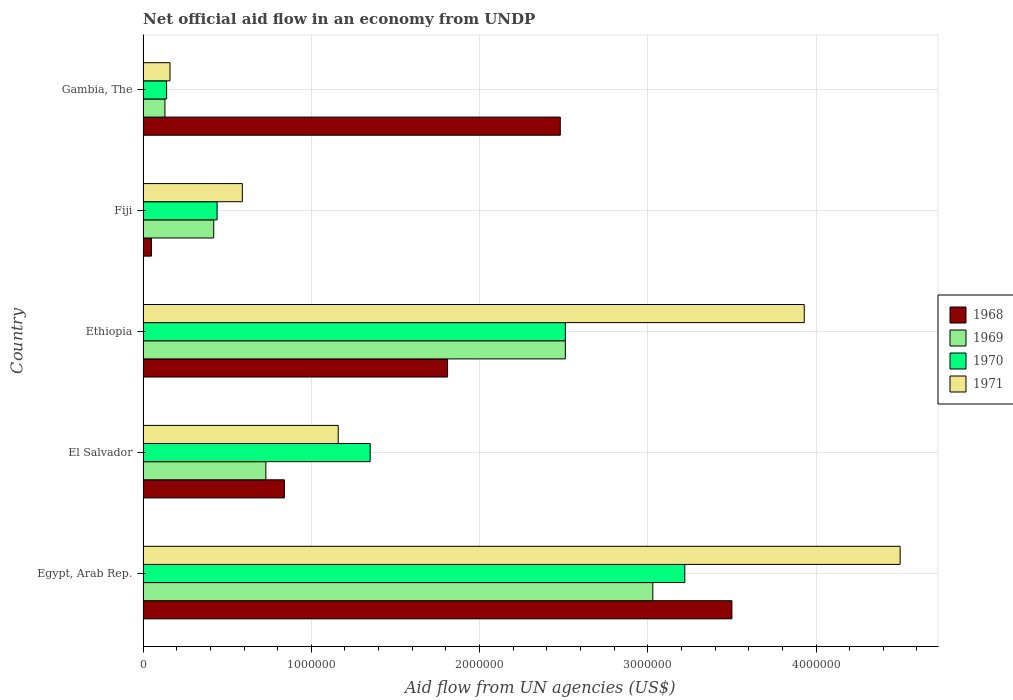How many groups of bars are there?
Give a very brief answer. 5. Are the number of bars per tick equal to the number of legend labels?
Your response must be concise. Yes. What is the label of the 5th group of bars from the top?
Keep it short and to the point. Egypt, Arab Rep. In how many cases, is the number of bars for a given country not equal to the number of legend labels?
Make the answer very short. 0. Across all countries, what is the maximum net official aid flow in 1970?
Your answer should be very brief. 3.22e+06. Across all countries, what is the minimum net official aid flow in 1969?
Keep it short and to the point. 1.30e+05. In which country was the net official aid flow in 1970 maximum?
Your answer should be compact. Egypt, Arab Rep. In which country was the net official aid flow in 1969 minimum?
Ensure brevity in your answer.  Gambia, The. What is the total net official aid flow in 1968 in the graph?
Keep it short and to the point. 8.68e+06. What is the difference between the net official aid flow in 1971 in El Salvador and that in Fiji?
Keep it short and to the point. 5.70e+05. What is the difference between the net official aid flow in 1968 in Egypt, Arab Rep. and the net official aid flow in 1970 in Gambia, The?
Make the answer very short. 3.36e+06. What is the average net official aid flow in 1970 per country?
Provide a succinct answer. 1.53e+06. What is the ratio of the net official aid flow in 1971 in Ethiopia to that in Fiji?
Offer a very short reply. 6.66. Is the difference between the net official aid flow in 1968 in El Salvador and Fiji greater than the difference between the net official aid flow in 1969 in El Salvador and Fiji?
Your response must be concise. Yes. What is the difference between the highest and the second highest net official aid flow in 1970?
Your response must be concise. 7.10e+05. What is the difference between the highest and the lowest net official aid flow in 1968?
Keep it short and to the point. 3.45e+06. In how many countries, is the net official aid flow in 1969 greater than the average net official aid flow in 1969 taken over all countries?
Provide a short and direct response. 2. What does the 3rd bar from the bottom in Ethiopia represents?
Your answer should be compact. 1970. Is it the case that in every country, the sum of the net official aid flow in 1969 and net official aid flow in 1970 is greater than the net official aid flow in 1971?
Offer a terse response. Yes. Does the graph contain grids?
Your response must be concise. Yes. What is the title of the graph?
Keep it short and to the point. Net official aid flow in an economy from UNDP. Does "2008" appear as one of the legend labels in the graph?
Keep it short and to the point. No. What is the label or title of the X-axis?
Your answer should be compact. Aid flow from UN agencies (US$). What is the label or title of the Y-axis?
Offer a very short reply. Country. What is the Aid flow from UN agencies (US$) in 1968 in Egypt, Arab Rep.?
Your answer should be very brief. 3.50e+06. What is the Aid flow from UN agencies (US$) of 1969 in Egypt, Arab Rep.?
Offer a very short reply. 3.03e+06. What is the Aid flow from UN agencies (US$) of 1970 in Egypt, Arab Rep.?
Your answer should be compact. 3.22e+06. What is the Aid flow from UN agencies (US$) in 1971 in Egypt, Arab Rep.?
Your response must be concise. 4.50e+06. What is the Aid flow from UN agencies (US$) in 1968 in El Salvador?
Provide a short and direct response. 8.40e+05. What is the Aid flow from UN agencies (US$) in 1969 in El Salvador?
Ensure brevity in your answer.  7.30e+05. What is the Aid flow from UN agencies (US$) in 1970 in El Salvador?
Give a very brief answer. 1.35e+06. What is the Aid flow from UN agencies (US$) in 1971 in El Salvador?
Keep it short and to the point. 1.16e+06. What is the Aid flow from UN agencies (US$) of 1968 in Ethiopia?
Provide a succinct answer. 1.81e+06. What is the Aid flow from UN agencies (US$) in 1969 in Ethiopia?
Provide a succinct answer. 2.51e+06. What is the Aid flow from UN agencies (US$) in 1970 in Ethiopia?
Your response must be concise. 2.51e+06. What is the Aid flow from UN agencies (US$) in 1971 in Ethiopia?
Offer a very short reply. 3.93e+06. What is the Aid flow from UN agencies (US$) in 1968 in Fiji?
Keep it short and to the point. 5.00e+04. What is the Aid flow from UN agencies (US$) in 1969 in Fiji?
Provide a succinct answer. 4.20e+05. What is the Aid flow from UN agencies (US$) in 1971 in Fiji?
Offer a very short reply. 5.90e+05. What is the Aid flow from UN agencies (US$) of 1968 in Gambia, The?
Make the answer very short. 2.48e+06. What is the Aid flow from UN agencies (US$) in 1969 in Gambia, The?
Offer a terse response. 1.30e+05. What is the Aid flow from UN agencies (US$) of 1970 in Gambia, The?
Make the answer very short. 1.40e+05. Across all countries, what is the maximum Aid flow from UN agencies (US$) in 1968?
Your answer should be very brief. 3.50e+06. Across all countries, what is the maximum Aid flow from UN agencies (US$) of 1969?
Offer a terse response. 3.03e+06. Across all countries, what is the maximum Aid flow from UN agencies (US$) in 1970?
Give a very brief answer. 3.22e+06. Across all countries, what is the maximum Aid flow from UN agencies (US$) of 1971?
Offer a very short reply. 4.50e+06. Across all countries, what is the minimum Aid flow from UN agencies (US$) of 1968?
Your response must be concise. 5.00e+04. Across all countries, what is the minimum Aid flow from UN agencies (US$) in 1970?
Offer a very short reply. 1.40e+05. What is the total Aid flow from UN agencies (US$) in 1968 in the graph?
Your response must be concise. 8.68e+06. What is the total Aid flow from UN agencies (US$) in 1969 in the graph?
Your answer should be compact. 6.82e+06. What is the total Aid flow from UN agencies (US$) of 1970 in the graph?
Provide a succinct answer. 7.66e+06. What is the total Aid flow from UN agencies (US$) in 1971 in the graph?
Make the answer very short. 1.03e+07. What is the difference between the Aid flow from UN agencies (US$) in 1968 in Egypt, Arab Rep. and that in El Salvador?
Offer a very short reply. 2.66e+06. What is the difference between the Aid flow from UN agencies (US$) in 1969 in Egypt, Arab Rep. and that in El Salvador?
Make the answer very short. 2.30e+06. What is the difference between the Aid flow from UN agencies (US$) of 1970 in Egypt, Arab Rep. and that in El Salvador?
Ensure brevity in your answer.  1.87e+06. What is the difference between the Aid flow from UN agencies (US$) in 1971 in Egypt, Arab Rep. and that in El Salvador?
Offer a terse response. 3.34e+06. What is the difference between the Aid flow from UN agencies (US$) of 1968 in Egypt, Arab Rep. and that in Ethiopia?
Your response must be concise. 1.69e+06. What is the difference between the Aid flow from UN agencies (US$) of 1969 in Egypt, Arab Rep. and that in Ethiopia?
Provide a succinct answer. 5.20e+05. What is the difference between the Aid flow from UN agencies (US$) of 1970 in Egypt, Arab Rep. and that in Ethiopia?
Your answer should be compact. 7.10e+05. What is the difference between the Aid flow from UN agencies (US$) in 1971 in Egypt, Arab Rep. and that in Ethiopia?
Offer a terse response. 5.70e+05. What is the difference between the Aid flow from UN agencies (US$) in 1968 in Egypt, Arab Rep. and that in Fiji?
Provide a succinct answer. 3.45e+06. What is the difference between the Aid flow from UN agencies (US$) of 1969 in Egypt, Arab Rep. and that in Fiji?
Your answer should be compact. 2.61e+06. What is the difference between the Aid flow from UN agencies (US$) of 1970 in Egypt, Arab Rep. and that in Fiji?
Provide a short and direct response. 2.78e+06. What is the difference between the Aid flow from UN agencies (US$) of 1971 in Egypt, Arab Rep. and that in Fiji?
Provide a short and direct response. 3.91e+06. What is the difference between the Aid flow from UN agencies (US$) in 1968 in Egypt, Arab Rep. and that in Gambia, The?
Your response must be concise. 1.02e+06. What is the difference between the Aid flow from UN agencies (US$) of 1969 in Egypt, Arab Rep. and that in Gambia, The?
Offer a very short reply. 2.90e+06. What is the difference between the Aid flow from UN agencies (US$) in 1970 in Egypt, Arab Rep. and that in Gambia, The?
Offer a very short reply. 3.08e+06. What is the difference between the Aid flow from UN agencies (US$) in 1971 in Egypt, Arab Rep. and that in Gambia, The?
Your answer should be very brief. 4.34e+06. What is the difference between the Aid flow from UN agencies (US$) in 1968 in El Salvador and that in Ethiopia?
Your response must be concise. -9.70e+05. What is the difference between the Aid flow from UN agencies (US$) of 1969 in El Salvador and that in Ethiopia?
Make the answer very short. -1.78e+06. What is the difference between the Aid flow from UN agencies (US$) in 1970 in El Salvador and that in Ethiopia?
Your answer should be very brief. -1.16e+06. What is the difference between the Aid flow from UN agencies (US$) in 1971 in El Salvador and that in Ethiopia?
Ensure brevity in your answer.  -2.77e+06. What is the difference between the Aid flow from UN agencies (US$) of 1968 in El Salvador and that in Fiji?
Make the answer very short. 7.90e+05. What is the difference between the Aid flow from UN agencies (US$) in 1970 in El Salvador and that in Fiji?
Provide a short and direct response. 9.10e+05. What is the difference between the Aid flow from UN agencies (US$) of 1971 in El Salvador and that in Fiji?
Your response must be concise. 5.70e+05. What is the difference between the Aid flow from UN agencies (US$) of 1968 in El Salvador and that in Gambia, The?
Provide a succinct answer. -1.64e+06. What is the difference between the Aid flow from UN agencies (US$) of 1969 in El Salvador and that in Gambia, The?
Provide a short and direct response. 6.00e+05. What is the difference between the Aid flow from UN agencies (US$) in 1970 in El Salvador and that in Gambia, The?
Offer a very short reply. 1.21e+06. What is the difference between the Aid flow from UN agencies (US$) in 1968 in Ethiopia and that in Fiji?
Your response must be concise. 1.76e+06. What is the difference between the Aid flow from UN agencies (US$) of 1969 in Ethiopia and that in Fiji?
Your answer should be compact. 2.09e+06. What is the difference between the Aid flow from UN agencies (US$) of 1970 in Ethiopia and that in Fiji?
Keep it short and to the point. 2.07e+06. What is the difference between the Aid flow from UN agencies (US$) in 1971 in Ethiopia and that in Fiji?
Offer a terse response. 3.34e+06. What is the difference between the Aid flow from UN agencies (US$) in 1968 in Ethiopia and that in Gambia, The?
Provide a short and direct response. -6.70e+05. What is the difference between the Aid flow from UN agencies (US$) of 1969 in Ethiopia and that in Gambia, The?
Ensure brevity in your answer.  2.38e+06. What is the difference between the Aid flow from UN agencies (US$) in 1970 in Ethiopia and that in Gambia, The?
Your answer should be very brief. 2.37e+06. What is the difference between the Aid flow from UN agencies (US$) of 1971 in Ethiopia and that in Gambia, The?
Offer a very short reply. 3.77e+06. What is the difference between the Aid flow from UN agencies (US$) of 1968 in Fiji and that in Gambia, The?
Make the answer very short. -2.43e+06. What is the difference between the Aid flow from UN agencies (US$) in 1969 in Fiji and that in Gambia, The?
Keep it short and to the point. 2.90e+05. What is the difference between the Aid flow from UN agencies (US$) in 1970 in Fiji and that in Gambia, The?
Provide a short and direct response. 3.00e+05. What is the difference between the Aid flow from UN agencies (US$) of 1968 in Egypt, Arab Rep. and the Aid flow from UN agencies (US$) of 1969 in El Salvador?
Your response must be concise. 2.77e+06. What is the difference between the Aid flow from UN agencies (US$) in 1968 in Egypt, Arab Rep. and the Aid flow from UN agencies (US$) in 1970 in El Salvador?
Offer a very short reply. 2.15e+06. What is the difference between the Aid flow from UN agencies (US$) in 1968 in Egypt, Arab Rep. and the Aid flow from UN agencies (US$) in 1971 in El Salvador?
Your answer should be very brief. 2.34e+06. What is the difference between the Aid flow from UN agencies (US$) in 1969 in Egypt, Arab Rep. and the Aid flow from UN agencies (US$) in 1970 in El Salvador?
Make the answer very short. 1.68e+06. What is the difference between the Aid flow from UN agencies (US$) of 1969 in Egypt, Arab Rep. and the Aid flow from UN agencies (US$) of 1971 in El Salvador?
Your answer should be very brief. 1.87e+06. What is the difference between the Aid flow from UN agencies (US$) in 1970 in Egypt, Arab Rep. and the Aid flow from UN agencies (US$) in 1971 in El Salvador?
Ensure brevity in your answer.  2.06e+06. What is the difference between the Aid flow from UN agencies (US$) of 1968 in Egypt, Arab Rep. and the Aid flow from UN agencies (US$) of 1969 in Ethiopia?
Your response must be concise. 9.90e+05. What is the difference between the Aid flow from UN agencies (US$) of 1968 in Egypt, Arab Rep. and the Aid flow from UN agencies (US$) of 1970 in Ethiopia?
Make the answer very short. 9.90e+05. What is the difference between the Aid flow from UN agencies (US$) of 1968 in Egypt, Arab Rep. and the Aid flow from UN agencies (US$) of 1971 in Ethiopia?
Your answer should be compact. -4.30e+05. What is the difference between the Aid flow from UN agencies (US$) of 1969 in Egypt, Arab Rep. and the Aid flow from UN agencies (US$) of 1970 in Ethiopia?
Your answer should be very brief. 5.20e+05. What is the difference between the Aid flow from UN agencies (US$) of 1969 in Egypt, Arab Rep. and the Aid flow from UN agencies (US$) of 1971 in Ethiopia?
Give a very brief answer. -9.00e+05. What is the difference between the Aid flow from UN agencies (US$) in 1970 in Egypt, Arab Rep. and the Aid flow from UN agencies (US$) in 1971 in Ethiopia?
Ensure brevity in your answer.  -7.10e+05. What is the difference between the Aid flow from UN agencies (US$) in 1968 in Egypt, Arab Rep. and the Aid flow from UN agencies (US$) in 1969 in Fiji?
Offer a terse response. 3.08e+06. What is the difference between the Aid flow from UN agencies (US$) in 1968 in Egypt, Arab Rep. and the Aid flow from UN agencies (US$) in 1970 in Fiji?
Your response must be concise. 3.06e+06. What is the difference between the Aid flow from UN agencies (US$) in 1968 in Egypt, Arab Rep. and the Aid flow from UN agencies (US$) in 1971 in Fiji?
Offer a terse response. 2.91e+06. What is the difference between the Aid flow from UN agencies (US$) of 1969 in Egypt, Arab Rep. and the Aid flow from UN agencies (US$) of 1970 in Fiji?
Ensure brevity in your answer.  2.59e+06. What is the difference between the Aid flow from UN agencies (US$) in 1969 in Egypt, Arab Rep. and the Aid flow from UN agencies (US$) in 1971 in Fiji?
Provide a succinct answer. 2.44e+06. What is the difference between the Aid flow from UN agencies (US$) in 1970 in Egypt, Arab Rep. and the Aid flow from UN agencies (US$) in 1971 in Fiji?
Give a very brief answer. 2.63e+06. What is the difference between the Aid flow from UN agencies (US$) in 1968 in Egypt, Arab Rep. and the Aid flow from UN agencies (US$) in 1969 in Gambia, The?
Provide a succinct answer. 3.37e+06. What is the difference between the Aid flow from UN agencies (US$) of 1968 in Egypt, Arab Rep. and the Aid flow from UN agencies (US$) of 1970 in Gambia, The?
Offer a very short reply. 3.36e+06. What is the difference between the Aid flow from UN agencies (US$) of 1968 in Egypt, Arab Rep. and the Aid flow from UN agencies (US$) of 1971 in Gambia, The?
Keep it short and to the point. 3.34e+06. What is the difference between the Aid flow from UN agencies (US$) of 1969 in Egypt, Arab Rep. and the Aid flow from UN agencies (US$) of 1970 in Gambia, The?
Offer a terse response. 2.89e+06. What is the difference between the Aid flow from UN agencies (US$) of 1969 in Egypt, Arab Rep. and the Aid flow from UN agencies (US$) of 1971 in Gambia, The?
Offer a terse response. 2.87e+06. What is the difference between the Aid flow from UN agencies (US$) in 1970 in Egypt, Arab Rep. and the Aid flow from UN agencies (US$) in 1971 in Gambia, The?
Your response must be concise. 3.06e+06. What is the difference between the Aid flow from UN agencies (US$) in 1968 in El Salvador and the Aid flow from UN agencies (US$) in 1969 in Ethiopia?
Give a very brief answer. -1.67e+06. What is the difference between the Aid flow from UN agencies (US$) of 1968 in El Salvador and the Aid flow from UN agencies (US$) of 1970 in Ethiopia?
Your answer should be compact. -1.67e+06. What is the difference between the Aid flow from UN agencies (US$) of 1968 in El Salvador and the Aid flow from UN agencies (US$) of 1971 in Ethiopia?
Ensure brevity in your answer.  -3.09e+06. What is the difference between the Aid flow from UN agencies (US$) of 1969 in El Salvador and the Aid flow from UN agencies (US$) of 1970 in Ethiopia?
Offer a terse response. -1.78e+06. What is the difference between the Aid flow from UN agencies (US$) in 1969 in El Salvador and the Aid flow from UN agencies (US$) in 1971 in Ethiopia?
Ensure brevity in your answer.  -3.20e+06. What is the difference between the Aid flow from UN agencies (US$) in 1970 in El Salvador and the Aid flow from UN agencies (US$) in 1971 in Ethiopia?
Provide a succinct answer. -2.58e+06. What is the difference between the Aid flow from UN agencies (US$) of 1968 in El Salvador and the Aid flow from UN agencies (US$) of 1969 in Fiji?
Offer a terse response. 4.20e+05. What is the difference between the Aid flow from UN agencies (US$) of 1968 in El Salvador and the Aid flow from UN agencies (US$) of 1971 in Fiji?
Make the answer very short. 2.50e+05. What is the difference between the Aid flow from UN agencies (US$) of 1969 in El Salvador and the Aid flow from UN agencies (US$) of 1971 in Fiji?
Your response must be concise. 1.40e+05. What is the difference between the Aid flow from UN agencies (US$) of 1970 in El Salvador and the Aid flow from UN agencies (US$) of 1971 in Fiji?
Provide a short and direct response. 7.60e+05. What is the difference between the Aid flow from UN agencies (US$) in 1968 in El Salvador and the Aid flow from UN agencies (US$) in 1969 in Gambia, The?
Your answer should be compact. 7.10e+05. What is the difference between the Aid flow from UN agencies (US$) of 1968 in El Salvador and the Aid flow from UN agencies (US$) of 1971 in Gambia, The?
Offer a terse response. 6.80e+05. What is the difference between the Aid flow from UN agencies (US$) in 1969 in El Salvador and the Aid flow from UN agencies (US$) in 1970 in Gambia, The?
Ensure brevity in your answer.  5.90e+05. What is the difference between the Aid flow from UN agencies (US$) of 1969 in El Salvador and the Aid flow from UN agencies (US$) of 1971 in Gambia, The?
Give a very brief answer. 5.70e+05. What is the difference between the Aid flow from UN agencies (US$) of 1970 in El Salvador and the Aid flow from UN agencies (US$) of 1971 in Gambia, The?
Your response must be concise. 1.19e+06. What is the difference between the Aid flow from UN agencies (US$) of 1968 in Ethiopia and the Aid flow from UN agencies (US$) of 1969 in Fiji?
Provide a short and direct response. 1.39e+06. What is the difference between the Aid flow from UN agencies (US$) of 1968 in Ethiopia and the Aid flow from UN agencies (US$) of 1970 in Fiji?
Provide a short and direct response. 1.37e+06. What is the difference between the Aid flow from UN agencies (US$) in 1968 in Ethiopia and the Aid flow from UN agencies (US$) in 1971 in Fiji?
Provide a short and direct response. 1.22e+06. What is the difference between the Aid flow from UN agencies (US$) of 1969 in Ethiopia and the Aid flow from UN agencies (US$) of 1970 in Fiji?
Give a very brief answer. 2.07e+06. What is the difference between the Aid flow from UN agencies (US$) in 1969 in Ethiopia and the Aid flow from UN agencies (US$) in 1971 in Fiji?
Your answer should be very brief. 1.92e+06. What is the difference between the Aid flow from UN agencies (US$) of 1970 in Ethiopia and the Aid flow from UN agencies (US$) of 1971 in Fiji?
Offer a terse response. 1.92e+06. What is the difference between the Aid flow from UN agencies (US$) in 1968 in Ethiopia and the Aid flow from UN agencies (US$) in 1969 in Gambia, The?
Your answer should be compact. 1.68e+06. What is the difference between the Aid flow from UN agencies (US$) in 1968 in Ethiopia and the Aid flow from UN agencies (US$) in 1970 in Gambia, The?
Ensure brevity in your answer.  1.67e+06. What is the difference between the Aid flow from UN agencies (US$) of 1968 in Ethiopia and the Aid flow from UN agencies (US$) of 1971 in Gambia, The?
Your answer should be very brief. 1.65e+06. What is the difference between the Aid flow from UN agencies (US$) of 1969 in Ethiopia and the Aid flow from UN agencies (US$) of 1970 in Gambia, The?
Ensure brevity in your answer.  2.37e+06. What is the difference between the Aid flow from UN agencies (US$) in 1969 in Ethiopia and the Aid flow from UN agencies (US$) in 1971 in Gambia, The?
Provide a succinct answer. 2.35e+06. What is the difference between the Aid flow from UN agencies (US$) of 1970 in Ethiopia and the Aid flow from UN agencies (US$) of 1971 in Gambia, The?
Give a very brief answer. 2.35e+06. What is the difference between the Aid flow from UN agencies (US$) of 1968 in Fiji and the Aid flow from UN agencies (US$) of 1969 in Gambia, The?
Give a very brief answer. -8.00e+04. What is the difference between the Aid flow from UN agencies (US$) of 1968 in Fiji and the Aid flow from UN agencies (US$) of 1970 in Gambia, The?
Offer a very short reply. -9.00e+04. What is the difference between the Aid flow from UN agencies (US$) of 1968 in Fiji and the Aid flow from UN agencies (US$) of 1971 in Gambia, The?
Ensure brevity in your answer.  -1.10e+05. What is the difference between the Aid flow from UN agencies (US$) in 1969 in Fiji and the Aid flow from UN agencies (US$) in 1970 in Gambia, The?
Offer a terse response. 2.80e+05. What is the difference between the Aid flow from UN agencies (US$) of 1970 in Fiji and the Aid flow from UN agencies (US$) of 1971 in Gambia, The?
Keep it short and to the point. 2.80e+05. What is the average Aid flow from UN agencies (US$) in 1968 per country?
Offer a very short reply. 1.74e+06. What is the average Aid flow from UN agencies (US$) in 1969 per country?
Provide a short and direct response. 1.36e+06. What is the average Aid flow from UN agencies (US$) in 1970 per country?
Provide a short and direct response. 1.53e+06. What is the average Aid flow from UN agencies (US$) in 1971 per country?
Offer a terse response. 2.07e+06. What is the difference between the Aid flow from UN agencies (US$) in 1968 and Aid flow from UN agencies (US$) in 1970 in Egypt, Arab Rep.?
Make the answer very short. 2.80e+05. What is the difference between the Aid flow from UN agencies (US$) of 1969 and Aid flow from UN agencies (US$) of 1971 in Egypt, Arab Rep.?
Give a very brief answer. -1.47e+06. What is the difference between the Aid flow from UN agencies (US$) in 1970 and Aid flow from UN agencies (US$) in 1971 in Egypt, Arab Rep.?
Make the answer very short. -1.28e+06. What is the difference between the Aid flow from UN agencies (US$) in 1968 and Aid flow from UN agencies (US$) in 1970 in El Salvador?
Make the answer very short. -5.10e+05. What is the difference between the Aid flow from UN agencies (US$) of 1968 and Aid flow from UN agencies (US$) of 1971 in El Salvador?
Your answer should be very brief. -3.20e+05. What is the difference between the Aid flow from UN agencies (US$) of 1969 and Aid flow from UN agencies (US$) of 1970 in El Salvador?
Keep it short and to the point. -6.20e+05. What is the difference between the Aid flow from UN agencies (US$) of 1969 and Aid flow from UN agencies (US$) of 1971 in El Salvador?
Offer a terse response. -4.30e+05. What is the difference between the Aid flow from UN agencies (US$) of 1970 and Aid flow from UN agencies (US$) of 1971 in El Salvador?
Offer a very short reply. 1.90e+05. What is the difference between the Aid flow from UN agencies (US$) in 1968 and Aid flow from UN agencies (US$) in 1969 in Ethiopia?
Keep it short and to the point. -7.00e+05. What is the difference between the Aid flow from UN agencies (US$) in 1968 and Aid flow from UN agencies (US$) in 1970 in Ethiopia?
Give a very brief answer. -7.00e+05. What is the difference between the Aid flow from UN agencies (US$) of 1968 and Aid flow from UN agencies (US$) of 1971 in Ethiopia?
Make the answer very short. -2.12e+06. What is the difference between the Aid flow from UN agencies (US$) in 1969 and Aid flow from UN agencies (US$) in 1971 in Ethiopia?
Give a very brief answer. -1.42e+06. What is the difference between the Aid flow from UN agencies (US$) of 1970 and Aid flow from UN agencies (US$) of 1971 in Ethiopia?
Keep it short and to the point. -1.42e+06. What is the difference between the Aid flow from UN agencies (US$) in 1968 and Aid flow from UN agencies (US$) in 1969 in Fiji?
Make the answer very short. -3.70e+05. What is the difference between the Aid flow from UN agencies (US$) of 1968 and Aid flow from UN agencies (US$) of 1970 in Fiji?
Keep it short and to the point. -3.90e+05. What is the difference between the Aid flow from UN agencies (US$) of 1968 and Aid flow from UN agencies (US$) of 1971 in Fiji?
Provide a succinct answer. -5.40e+05. What is the difference between the Aid flow from UN agencies (US$) of 1969 and Aid flow from UN agencies (US$) of 1970 in Fiji?
Offer a very short reply. -2.00e+04. What is the difference between the Aid flow from UN agencies (US$) of 1969 and Aid flow from UN agencies (US$) of 1971 in Fiji?
Provide a short and direct response. -1.70e+05. What is the difference between the Aid flow from UN agencies (US$) of 1968 and Aid flow from UN agencies (US$) of 1969 in Gambia, The?
Your response must be concise. 2.35e+06. What is the difference between the Aid flow from UN agencies (US$) of 1968 and Aid flow from UN agencies (US$) of 1970 in Gambia, The?
Give a very brief answer. 2.34e+06. What is the difference between the Aid flow from UN agencies (US$) in 1968 and Aid flow from UN agencies (US$) in 1971 in Gambia, The?
Your answer should be compact. 2.32e+06. What is the difference between the Aid flow from UN agencies (US$) of 1970 and Aid flow from UN agencies (US$) of 1971 in Gambia, The?
Your answer should be compact. -2.00e+04. What is the ratio of the Aid flow from UN agencies (US$) in 1968 in Egypt, Arab Rep. to that in El Salvador?
Offer a terse response. 4.17. What is the ratio of the Aid flow from UN agencies (US$) in 1969 in Egypt, Arab Rep. to that in El Salvador?
Provide a succinct answer. 4.15. What is the ratio of the Aid flow from UN agencies (US$) in 1970 in Egypt, Arab Rep. to that in El Salvador?
Offer a terse response. 2.39. What is the ratio of the Aid flow from UN agencies (US$) in 1971 in Egypt, Arab Rep. to that in El Salvador?
Provide a succinct answer. 3.88. What is the ratio of the Aid flow from UN agencies (US$) in 1968 in Egypt, Arab Rep. to that in Ethiopia?
Keep it short and to the point. 1.93. What is the ratio of the Aid flow from UN agencies (US$) of 1969 in Egypt, Arab Rep. to that in Ethiopia?
Provide a short and direct response. 1.21. What is the ratio of the Aid flow from UN agencies (US$) of 1970 in Egypt, Arab Rep. to that in Ethiopia?
Ensure brevity in your answer.  1.28. What is the ratio of the Aid flow from UN agencies (US$) in 1971 in Egypt, Arab Rep. to that in Ethiopia?
Provide a short and direct response. 1.15. What is the ratio of the Aid flow from UN agencies (US$) of 1969 in Egypt, Arab Rep. to that in Fiji?
Keep it short and to the point. 7.21. What is the ratio of the Aid flow from UN agencies (US$) of 1970 in Egypt, Arab Rep. to that in Fiji?
Your answer should be very brief. 7.32. What is the ratio of the Aid flow from UN agencies (US$) in 1971 in Egypt, Arab Rep. to that in Fiji?
Your response must be concise. 7.63. What is the ratio of the Aid flow from UN agencies (US$) of 1968 in Egypt, Arab Rep. to that in Gambia, The?
Your answer should be very brief. 1.41. What is the ratio of the Aid flow from UN agencies (US$) in 1969 in Egypt, Arab Rep. to that in Gambia, The?
Offer a very short reply. 23.31. What is the ratio of the Aid flow from UN agencies (US$) of 1970 in Egypt, Arab Rep. to that in Gambia, The?
Make the answer very short. 23. What is the ratio of the Aid flow from UN agencies (US$) in 1971 in Egypt, Arab Rep. to that in Gambia, The?
Your answer should be compact. 28.12. What is the ratio of the Aid flow from UN agencies (US$) in 1968 in El Salvador to that in Ethiopia?
Provide a short and direct response. 0.46. What is the ratio of the Aid flow from UN agencies (US$) of 1969 in El Salvador to that in Ethiopia?
Make the answer very short. 0.29. What is the ratio of the Aid flow from UN agencies (US$) of 1970 in El Salvador to that in Ethiopia?
Give a very brief answer. 0.54. What is the ratio of the Aid flow from UN agencies (US$) of 1971 in El Salvador to that in Ethiopia?
Make the answer very short. 0.3. What is the ratio of the Aid flow from UN agencies (US$) in 1969 in El Salvador to that in Fiji?
Your response must be concise. 1.74. What is the ratio of the Aid flow from UN agencies (US$) of 1970 in El Salvador to that in Fiji?
Give a very brief answer. 3.07. What is the ratio of the Aid flow from UN agencies (US$) of 1971 in El Salvador to that in Fiji?
Provide a short and direct response. 1.97. What is the ratio of the Aid flow from UN agencies (US$) of 1968 in El Salvador to that in Gambia, The?
Your answer should be compact. 0.34. What is the ratio of the Aid flow from UN agencies (US$) of 1969 in El Salvador to that in Gambia, The?
Ensure brevity in your answer.  5.62. What is the ratio of the Aid flow from UN agencies (US$) in 1970 in El Salvador to that in Gambia, The?
Offer a very short reply. 9.64. What is the ratio of the Aid flow from UN agencies (US$) in 1971 in El Salvador to that in Gambia, The?
Provide a short and direct response. 7.25. What is the ratio of the Aid flow from UN agencies (US$) in 1968 in Ethiopia to that in Fiji?
Provide a short and direct response. 36.2. What is the ratio of the Aid flow from UN agencies (US$) in 1969 in Ethiopia to that in Fiji?
Give a very brief answer. 5.98. What is the ratio of the Aid flow from UN agencies (US$) in 1970 in Ethiopia to that in Fiji?
Your answer should be very brief. 5.7. What is the ratio of the Aid flow from UN agencies (US$) of 1971 in Ethiopia to that in Fiji?
Give a very brief answer. 6.66. What is the ratio of the Aid flow from UN agencies (US$) of 1968 in Ethiopia to that in Gambia, The?
Your answer should be compact. 0.73. What is the ratio of the Aid flow from UN agencies (US$) in 1969 in Ethiopia to that in Gambia, The?
Your answer should be very brief. 19.31. What is the ratio of the Aid flow from UN agencies (US$) in 1970 in Ethiopia to that in Gambia, The?
Offer a terse response. 17.93. What is the ratio of the Aid flow from UN agencies (US$) of 1971 in Ethiopia to that in Gambia, The?
Your response must be concise. 24.56. What is the ratio of the Aid flow from UN agencies (US$) of 1968 in Fiji to that in Gambia, The?
Your answer should be compact. 0.02. What is the ratio of the Aid flow from UN agencies (US$) in 1969 in Fiji to that in Gambia, The?
Your answer should be very brief. 3.23. What is the ratio of the Aid flow from UN agencies (US$) in 1970 in Fiji to that in Gambia, The?
Keep it short and to the point. 3.14. What is the ratio of the Aid flow from UN agencies (US$) in 1971 in Fiji to that in Gambia, The?
Keep it short and to the point. 3.69. What is the difference between the highest and the second highest Aid flow from UN agencies (US$) of 1968?
Offer a very short reply. 1.02e+06. What is the difference between the highest and the second highest Aid flow from UN agencies (US$) of 1969?
Your answer should be very brief. 5.20e+05. What is the difference between the highest and the second highest Aid flow from UN agencies (US$) of 1970?
Ensure brevity in your answer.  7.10e+05. What is the difference between the highest and the second highest Aid flow from UN agencies (US$) in 1971?
Ensure brevity in your answer.  5.70e+05. What is the difference between the highest and the lowest Aid flow from UN agencies (US$) of 1968?
Provide a short and direct response. 3.45e+06. What is the difference between the highest and the lowest Aid flow from UN agencies (US$) in 1969?
Make the answer very short. 2.90e+06. What is the difference between the highest and the lowest Aid flow from UN agencies (US$) of 1970?
Ensure brevity in your answer.  3.08e+06. What is the difference between the highest and the lowest Aid flow from UN agencies (US$) in 1971?
Your answer should be very brief. 4.34e+06. 